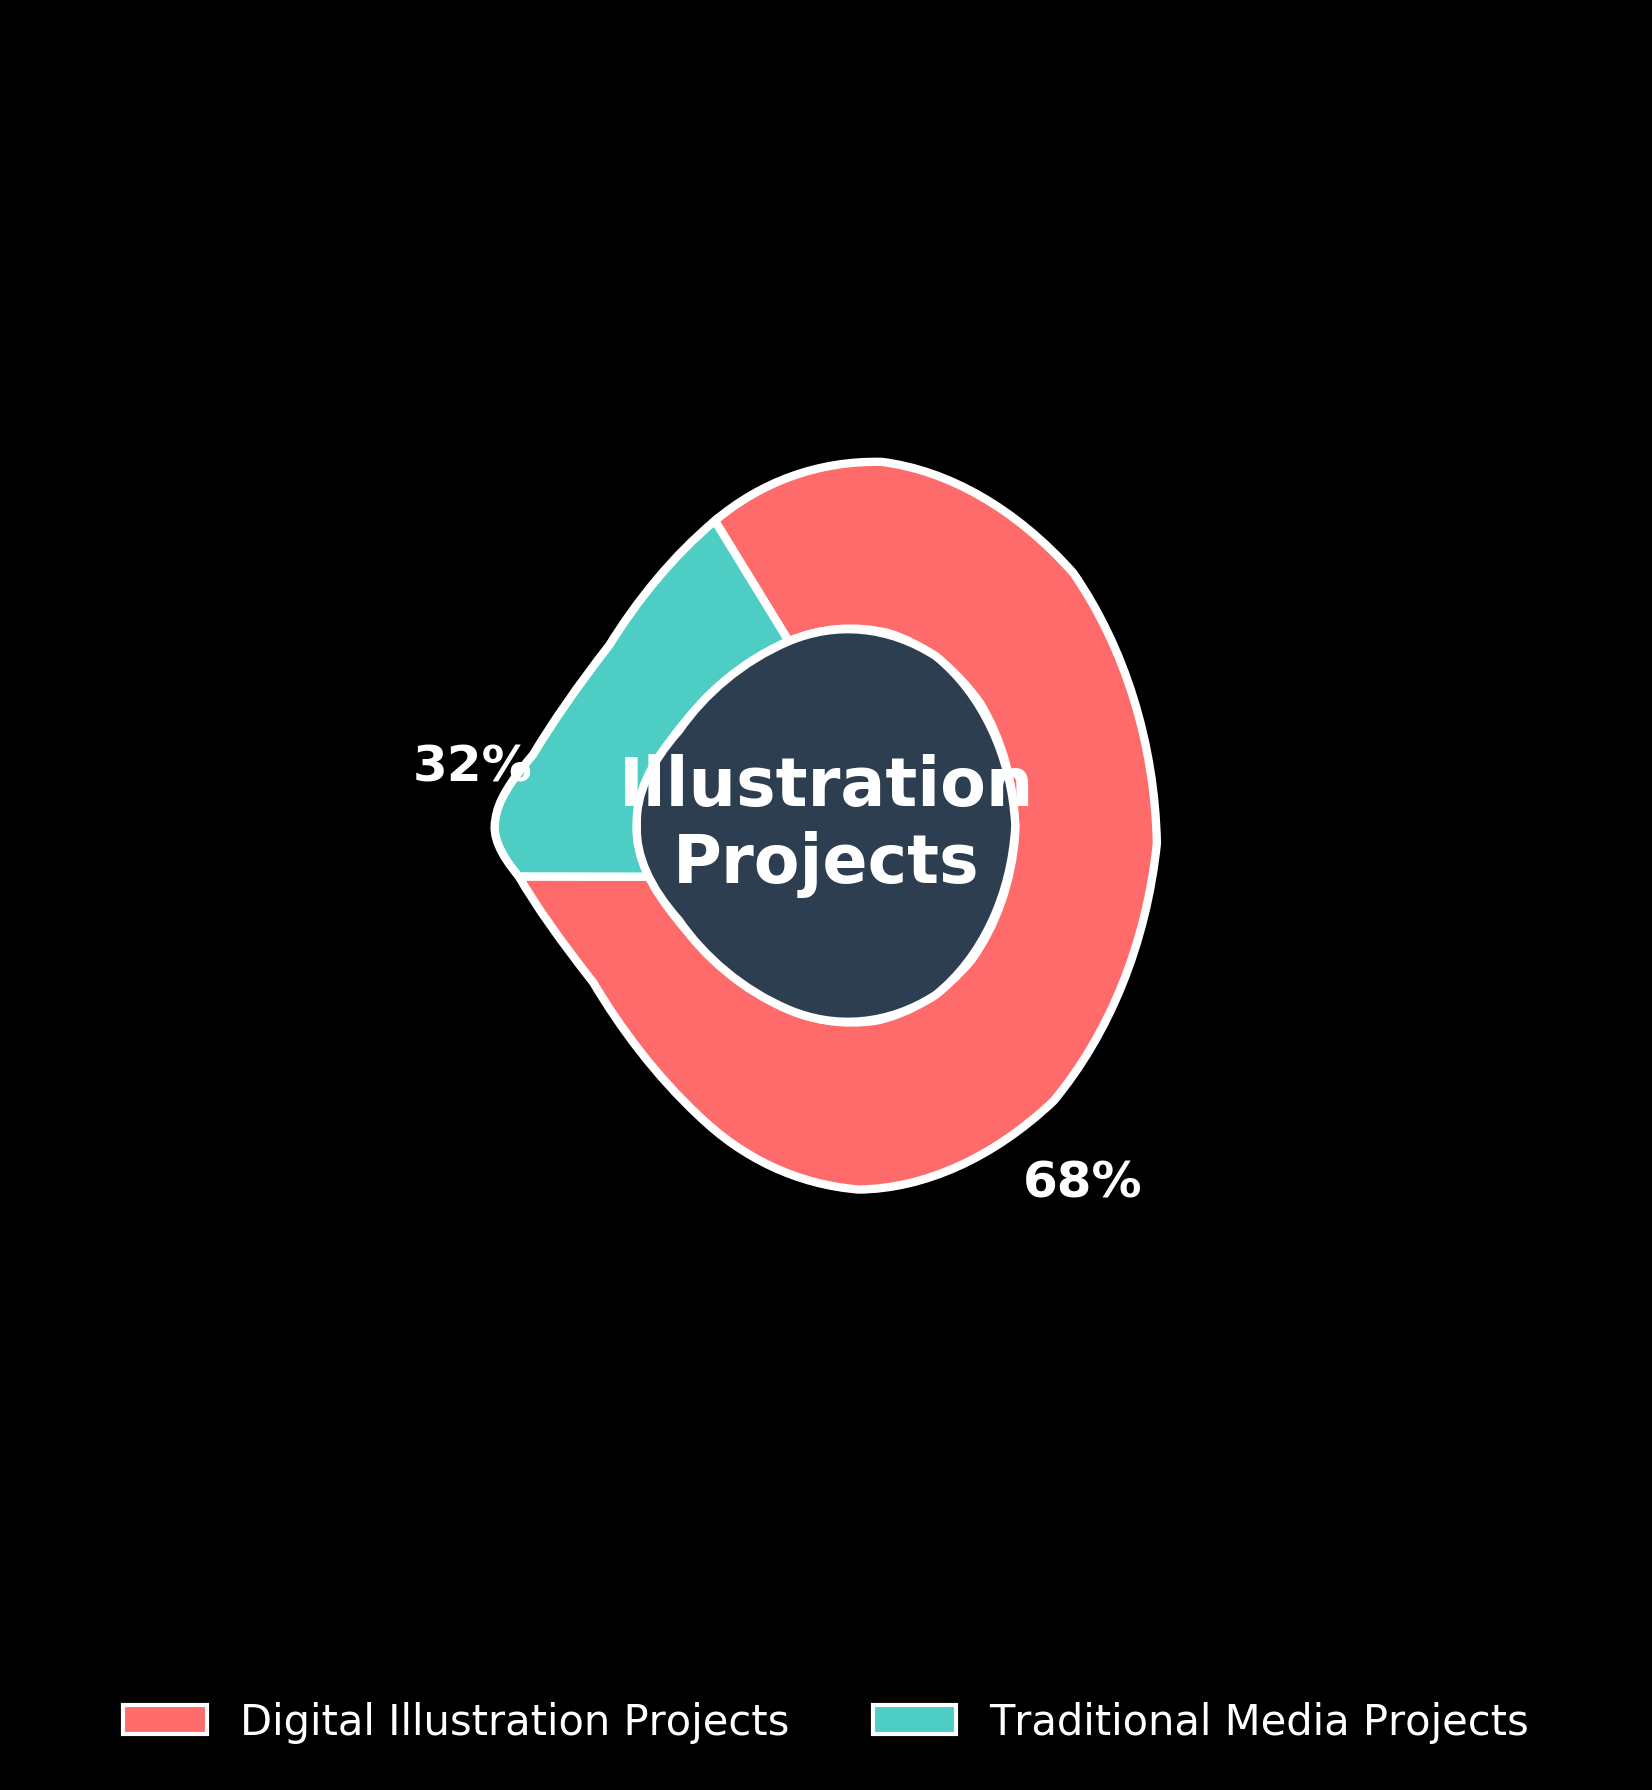What is the percentage of digital illustration projects? The percentage is directly indicated on the gauge chart. The number beside the digital illustration segment shows 68%.
Answer: 68% What colors represent the digital and traditional media projects? The chart uses colors to distinguish between the categories. The digital projects are in a specific red hue, while traditional media projects are in a cyan-like hue.
Answer: Red and Cyan Which type of project has a higher completion percentage? By comparing the two segments, it's clear that the digital illustration segment is larger and labeled with 68%, whereas the traditional segment is smaller with 32%. Hence, digital illustration projects have a higher percentage.
Answer: Digital illustration projects What is the total percentage represented by both project types? The total percentage is the sum of both categories shown in the chart: 68% (digital) + 32% (traditional) = 100%.
Answer: 100% Which segment is larger: digital illustration or traditional media projects? By observing the gauge, the digital illustration segment is larger as it spans a greater arc compared to the traditional segment.
Answer: Digital illustration If the total number of illustration projects is 50, how many belong to traditional media? We know that 32% of the projects are traditional media. By multiplying 32% by the total projects: 0.32 * 50 = 16.
Answer: 16 On the gauge chart, how many degrees does the traditional media segment span? Each percentage point corresponds to 3.6 degrees: 32% * 3.6 = 115.2 degrees for traditional media projects.
Answer: 115.2 degrees What is the difference in percentage points between digital and traditional illustration projects? The difference between the digital projects (68%) and traditional (32%) is calculated as 68% - 32% = 36%.
Answer: 36% How are the segments labeled on the gauge chart? The segments are labeled with their respective percentages and positioned along the arcs of the gauge chart. "Digital Illustration Projects" are labeled with 68% and "Traditional Media Projects" with 32%.
Answer: With percentages What is displayed at the center of the gauge chart? The center of the gauge chart contains a textual description that reads "Illustration Projects", indicating the overall category.
Answer: Illustration Projects 